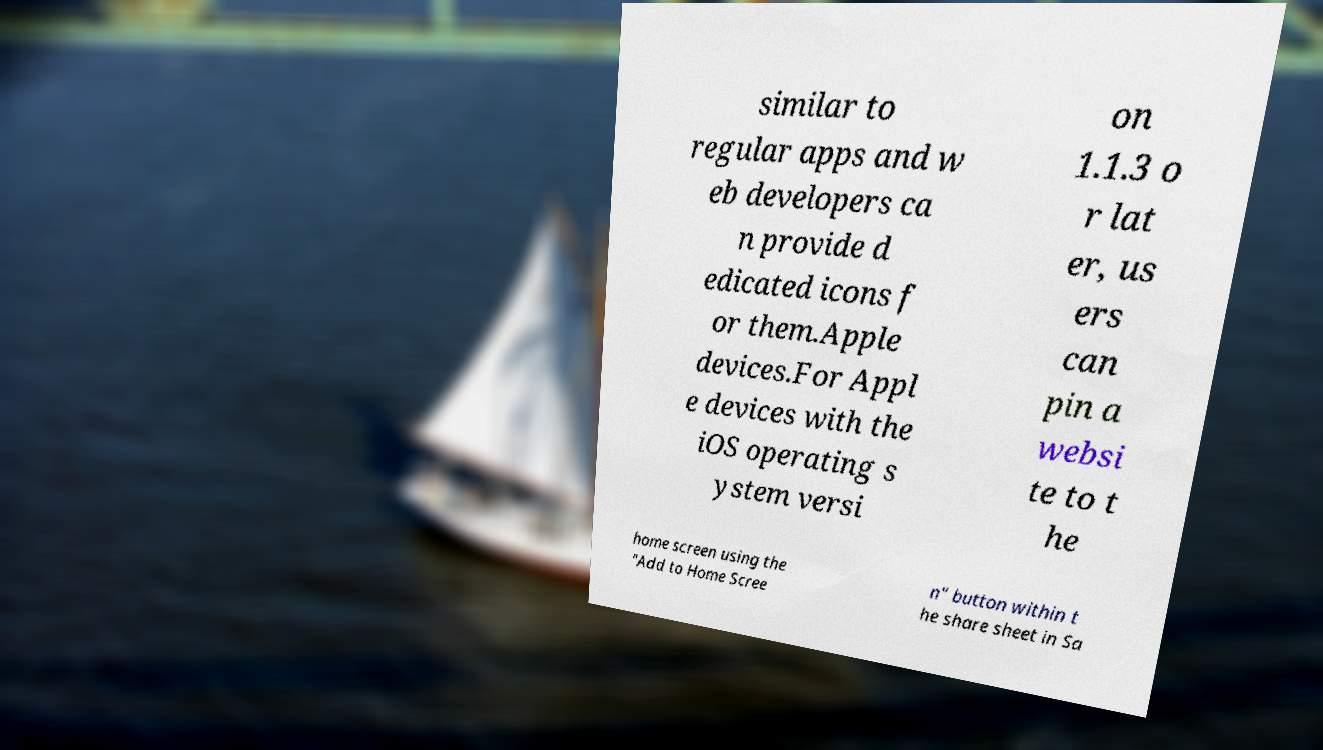Please read and relay the text visible in this image. What does it say? similar to regular apps and w eb developers ca n provide d edicated icons f or them.Apple devices.For Appl e devices with the iOS operating s ystem versi on 1.1.3 o r lat er, us ers can pin a websi te to t he home screen using the "Add to Home Scree n" button within t he share sheet in Sa 